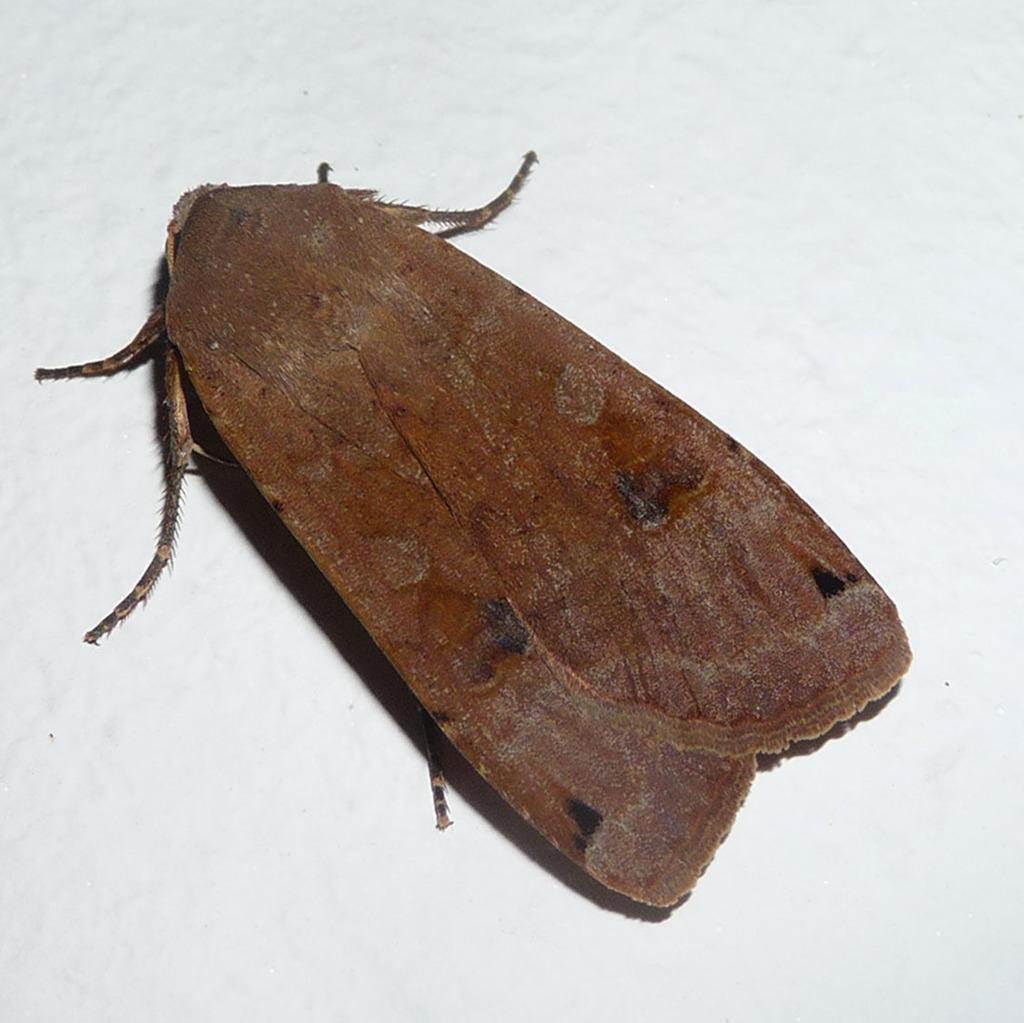What type of creature is present in the image? There is an insect in the image. Where is the insect located? The insect is on a wall. What is the color of the wall? The wall is off-white in color. In what type of setting is the insect located? The image is taken in a room. What type of beetle can be seen whistling in the image? There is no beetle present in the image, and no creature is shown whistling. What type of can is visible in the image? There is no can present in the image. 